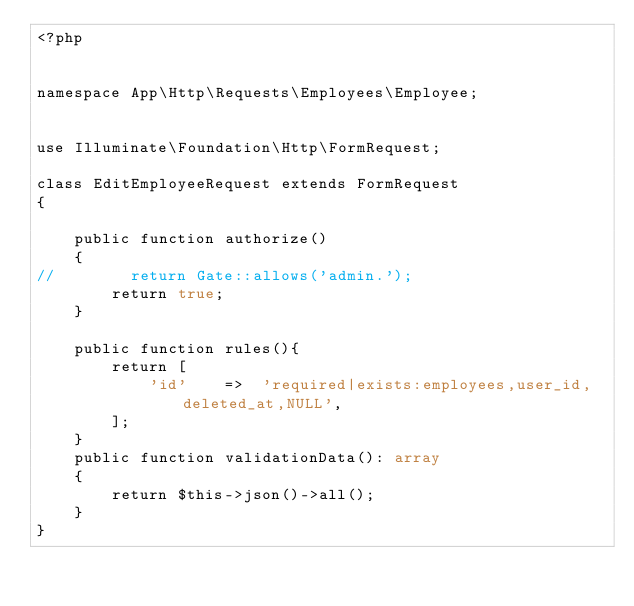<code> <loc_0><loc_0><loc_500><loc_500><_PHP_><?php


namespace App\Http\Requests\Employees\Employee;


use Illuminate\Foundation\Http\FormRequest;

class EditEmployeeRequest extends FormRequest
{

    public function authorize()
    {
//        return Gate::allows('admin.');
        return true;
    }

    public function rules(){
        return [
            'id'    =>  'required|exists:employees,user_id,deleted_at,NULL',
        ];
    }
    public function validationData(): array
    {
        return $this->json()->all();
    }
}
</code> 